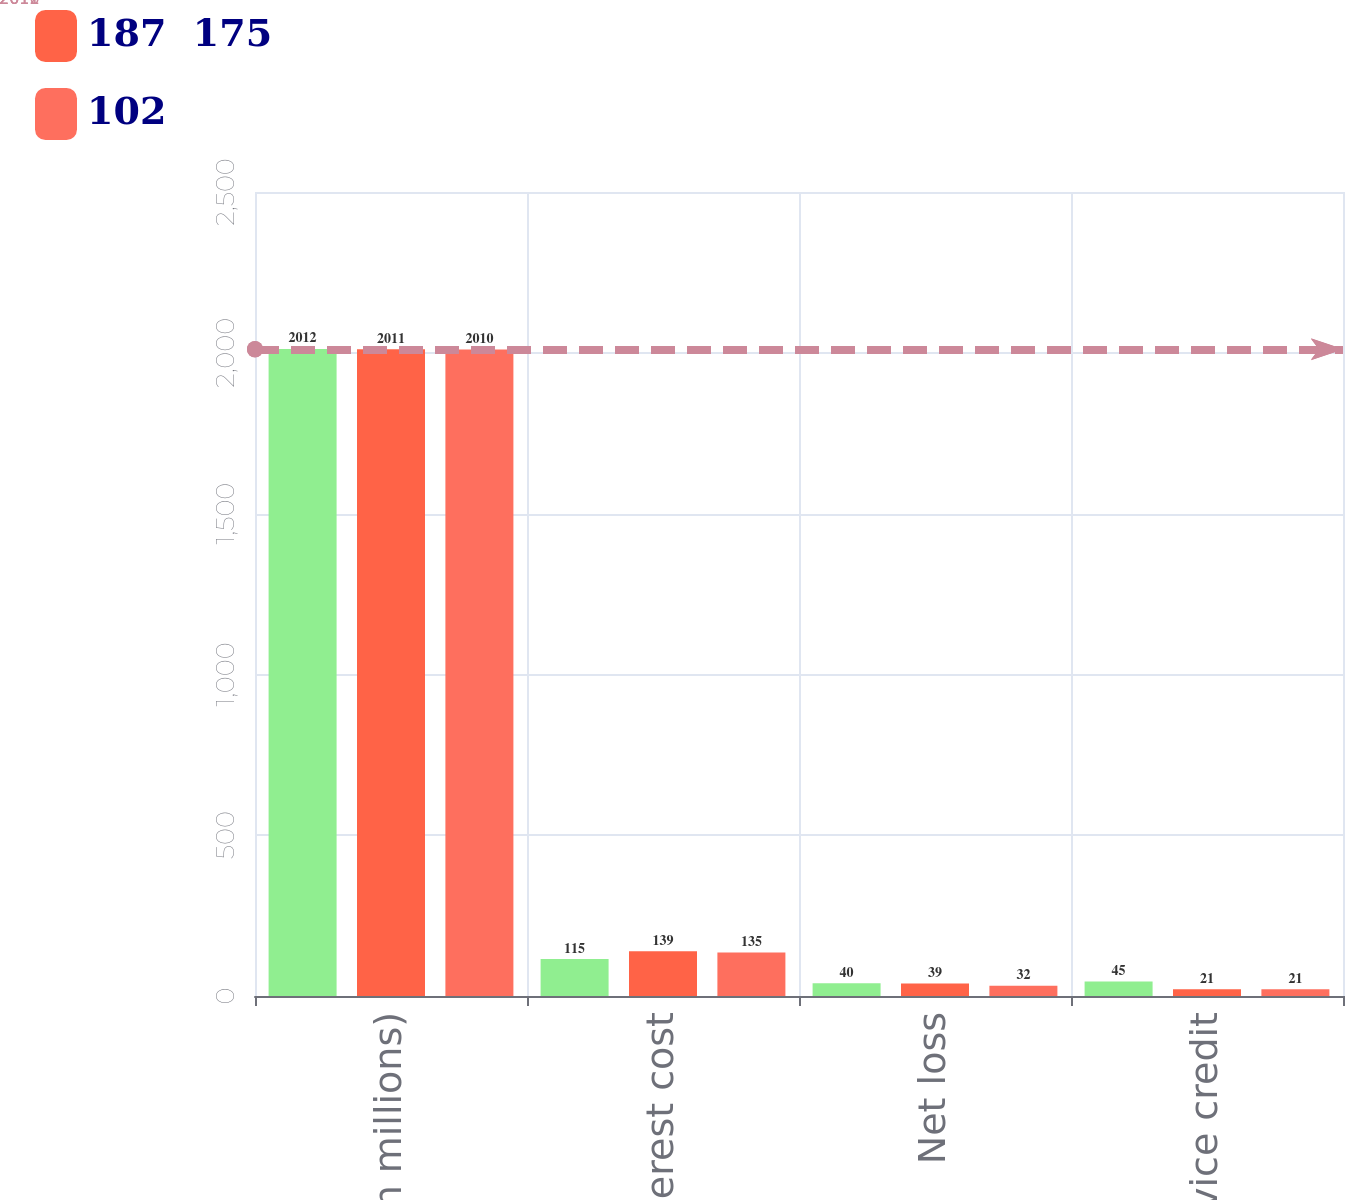<chart> <loc_0><loc_0><loc_500><loc_500><stacked_bar_chart><ecel><fcel>(in millions)<fcel>Interest cost<fcel>Net loss<fcel>Prior service credit<nl><fcel>nan<fcel>2012<fcel>115<fcel>40<fcel>45<nl><fcel>187  175<fcel>2011<fcel>139<fcel>39<fcel>21<nl><fcel>102<fcel>2010<fcel>135<fcel>32<fcel>21<nl></chart> 